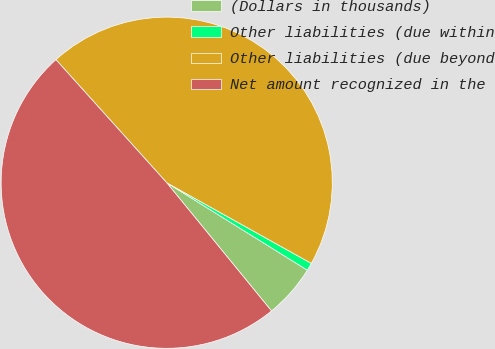Convert chart. <chart><loc_0><loc_0><loc_500><loc_500><pie_chart><fcel>(Dollars in thousands)<fcel>Other liabilities (due within<fcel>Other liabilities (due beyond<fcel>Net amount recognized in the<nl><fcel>5.24%<fcel>0.76%<fcel>44.76%<fcel>49.24%<nl></chart> 